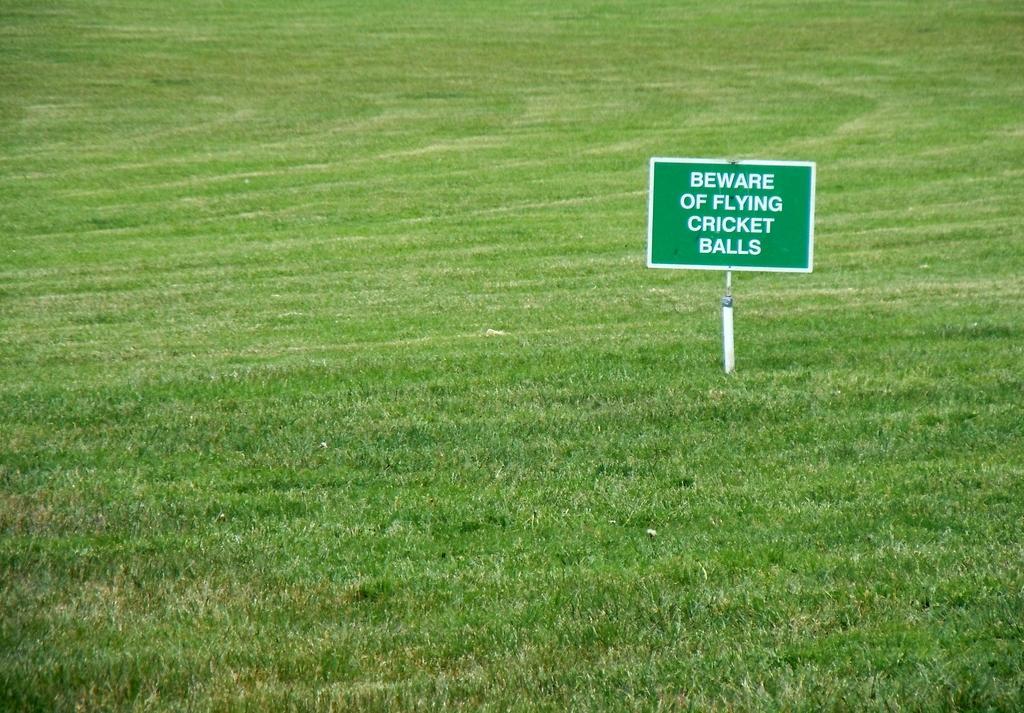How would you summarize this image in a sentence or two? In the foreground of this image, there is grass and a board with some text written on it as " BEWARE OF FLYING CRICKET BALLS" on it. 